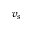<formula> <loc_0><loc_0><loc_500><loc_500>v _ { s }</formula> 